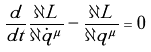Convert formula to latex. <formula><loc_0><loc_0><loc_500><loc_500>\frac { d } { d t } \frac { \partial L } { \partial \dot { q } ^ { \mu } } - \frac { \partial L } { \partial q ^ { \mu } } = 0</formula> 